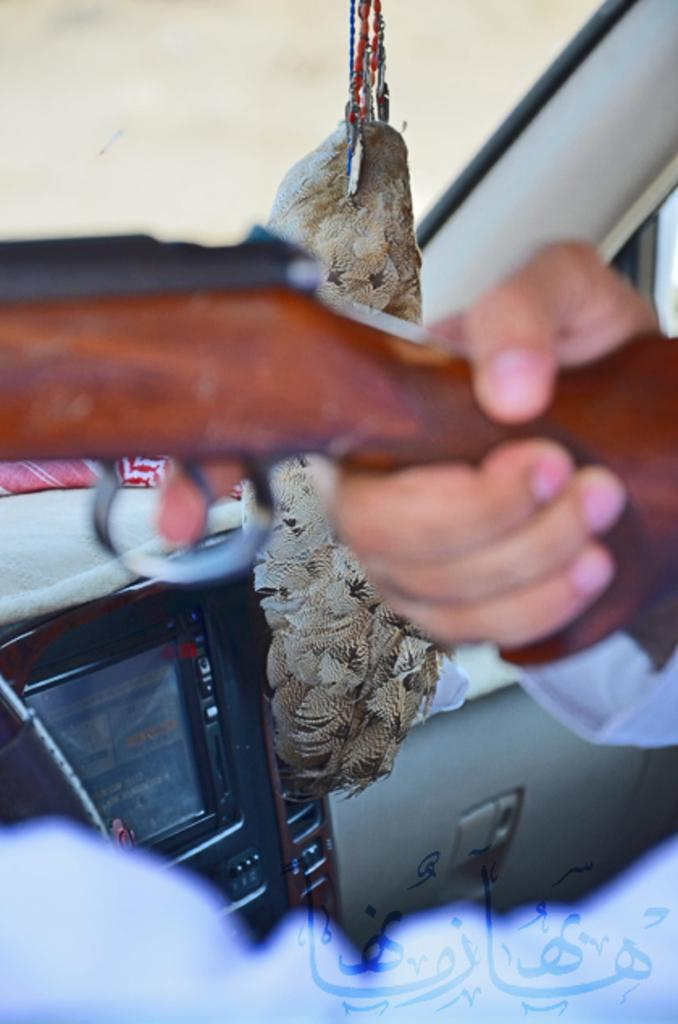What is the person in the image holding? The person is holding a gun in the image. What can be seen in the background of the image? There is a music box and a decorative object in the background of the image. Where is the person located in the image? The person is inside a vehicle in the image. How many friends are visible in the image? There are no friends visible in the image. What type of gate can be seen in the image? There is no gate present in the image. 